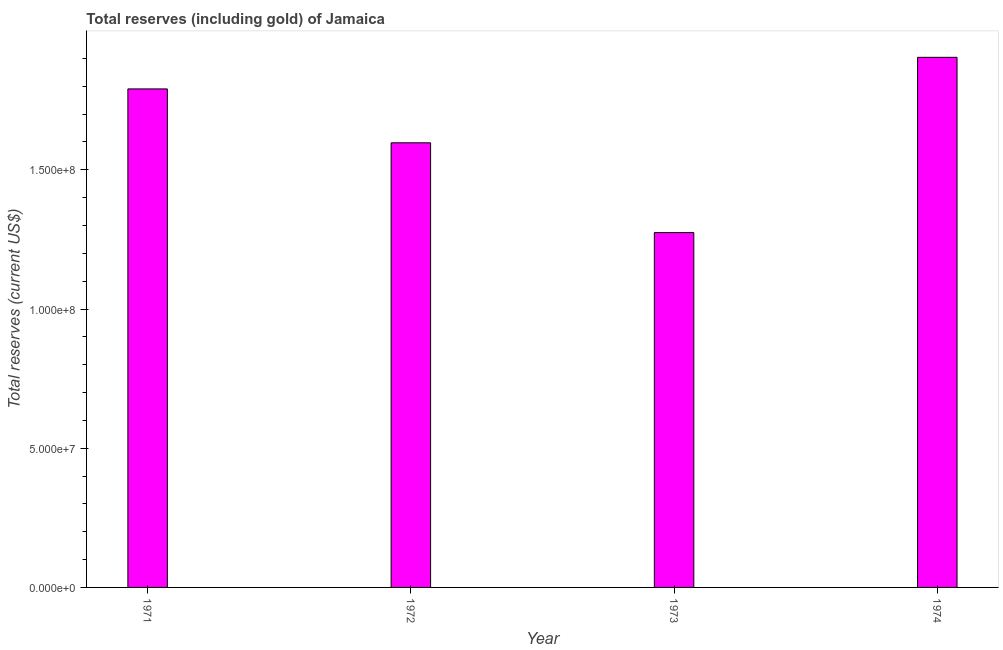Does the graph contain any zero values?
Your response must be concise. No. Does the graph contain grids?
Provide a succinct answer. No. What is the title of the graph?
Keep it short and to the point. Total reserves (including gold) of Jamaica. What is the label or title of the X-axis?
Your response must be concise. Year. What is the label or title of the Y-axis?
Make the answer very short. Total reserves (current US$). What is the total reserves (including gold) in 1971?
Your answer should be very brief. 1.79e+08. Across all years, what is the maximum total reserves (including gold)?
Make the answer very short. 1.90e+08. Across all years, what is the minimum total reserves (including gold)?
Offer a very short reply. 1.27e+08. In which year was the total reserves (including gold) maximum?
Offer a terse response. 1974. What is the sum of the total reserves (including gold)?
Your answer should be very brief. 6.57e+08. What is the difference between the total reserves (including gold) in 1972 and 1973?
Your answer should be very brief. 3.22e+07. What is the average total reserves (including gold) per year?
Offer a terse response. 1.64e+08. What is the median total reserves (including gold)?
Provide a short and direct response. 1.69e+08. In how many years, is the total reserves (including gold) greater than 70000000 US$?
Make the answer very short. 4. What is the ratio of the total reserves (including gold) in 1972 to that in 1973?
Your answer should be compact. 1.25. Is the total reserves (including gold) in 1971 less than that in 1972?
Provide a short and direct response. No. Is the difference between the total reserves (including gold) in 1971 and 1974 greater than the difference between any two years?
Offer a terse response. No. What is the difference between the highest and the second highest total reserves (including gold)?
Your answer should be very brief. 1.13e+07. Is the sum of the total reserves (including gold) in 1971 and 1972 greater than the maximum total reserves (including gold) across all years?
Provide a succinct answer. Yes. What is the difference between the highest and the lowest total reserves (including gold)?
Ensure brevity in your answer.  6.29e+07. In how many years, is the total reserves (including gold) greater than the average total reserves (including gold) taken over all years?
Keep it short and to the point. 2. How many bars are there?
Your answer should be compact. 4. How many years are there in the graph?
Keep it short and to the point. 4. What is the difference between two consecutive major ticks on the Y-axis?
Your answer should be very brief. 5.00e+07. Are the values on the major ticks of Y-axis written in scientific E-notation?
Offer a very short reply. Yes. What is the Total reserves (current US$) of 1971?
Make the answer very short. 1.79e+08. What is the Total reserves (current US$) of 1972?
Your answer should be very brief. 1.60e+08. What is the Total reserves (current US$) of 1973?
Your answer should be very brief. 1.27e+08. What is the Total reserves (current US$) in 1974?
Offer a very short reply. 1.90e+08. What is the difference between the Total reserves (current US$) in 1971 and 1972?
Offer a terse response. 1.94e+07. What is the difference between the Total reserves (current US$) in 1971 and 1973?
Provide a short and direct response. 5.16e+07. What is the difference between the Total reserves (current US$) in 1971 and 1974?
Your answer should be very brief. -1.13e+07. What is the difference between the Total reserves (current US$) in 1972 and 1973?
Ensure brevity in your answer.  3.22e+07. What is the difference between the Total reserves (current US$) in 1972 and 1974?
Make the answer very short. -3.07e+07. What is the difference between the Total reserves (current US$) in 1973 and 1974?
Your answer should be compact. -6.29e+07. What is the ratio of the Total reserves (current US$) in 1971 to that in 1972?
Your response must be concise. 1.12. What is the ratio of the Total reserves (current US$) in 1971 to that in 1973?
Offer a very short reply. 1.41. What is the ratio of the Total reserves (current US$) in 1972 to that in 1973?
Your answer should be very brief. 1.25. What is the ratio of the Total reserves (current US$) in 1972 to that in 1974?
Make the answer very short. 0.84. What is the ratio of the Total reserves (current US$) in 1973 to that in 1974?
Ensure brevity in your answer.  0.67. 